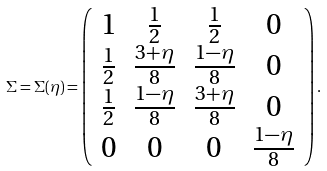Convert formula to latex. <formula><loc_0><loc_0><loc_500><loc_500>\Sigma = \Sigma ( \eta ) = \left ( \begin{array} { c c c c } 1 & \frac { 1 } { 2 } & \frac { 1 } { 2 } & 0 \\ \frac { 1 } { 2 } & \frac { 3 + \eta } { 8 } & \frac { 1 - \eta } { 8 } & 0 \\ \frac { 1 } { 2 } & \frac { 1 - \eta } { 8 } & \frac { 3 + \eta } { 8 } & 0 \\ 0 & 0 & 0 & \frac { 1 - \eta } { 8 } \end{array} \right ) .</formula> 